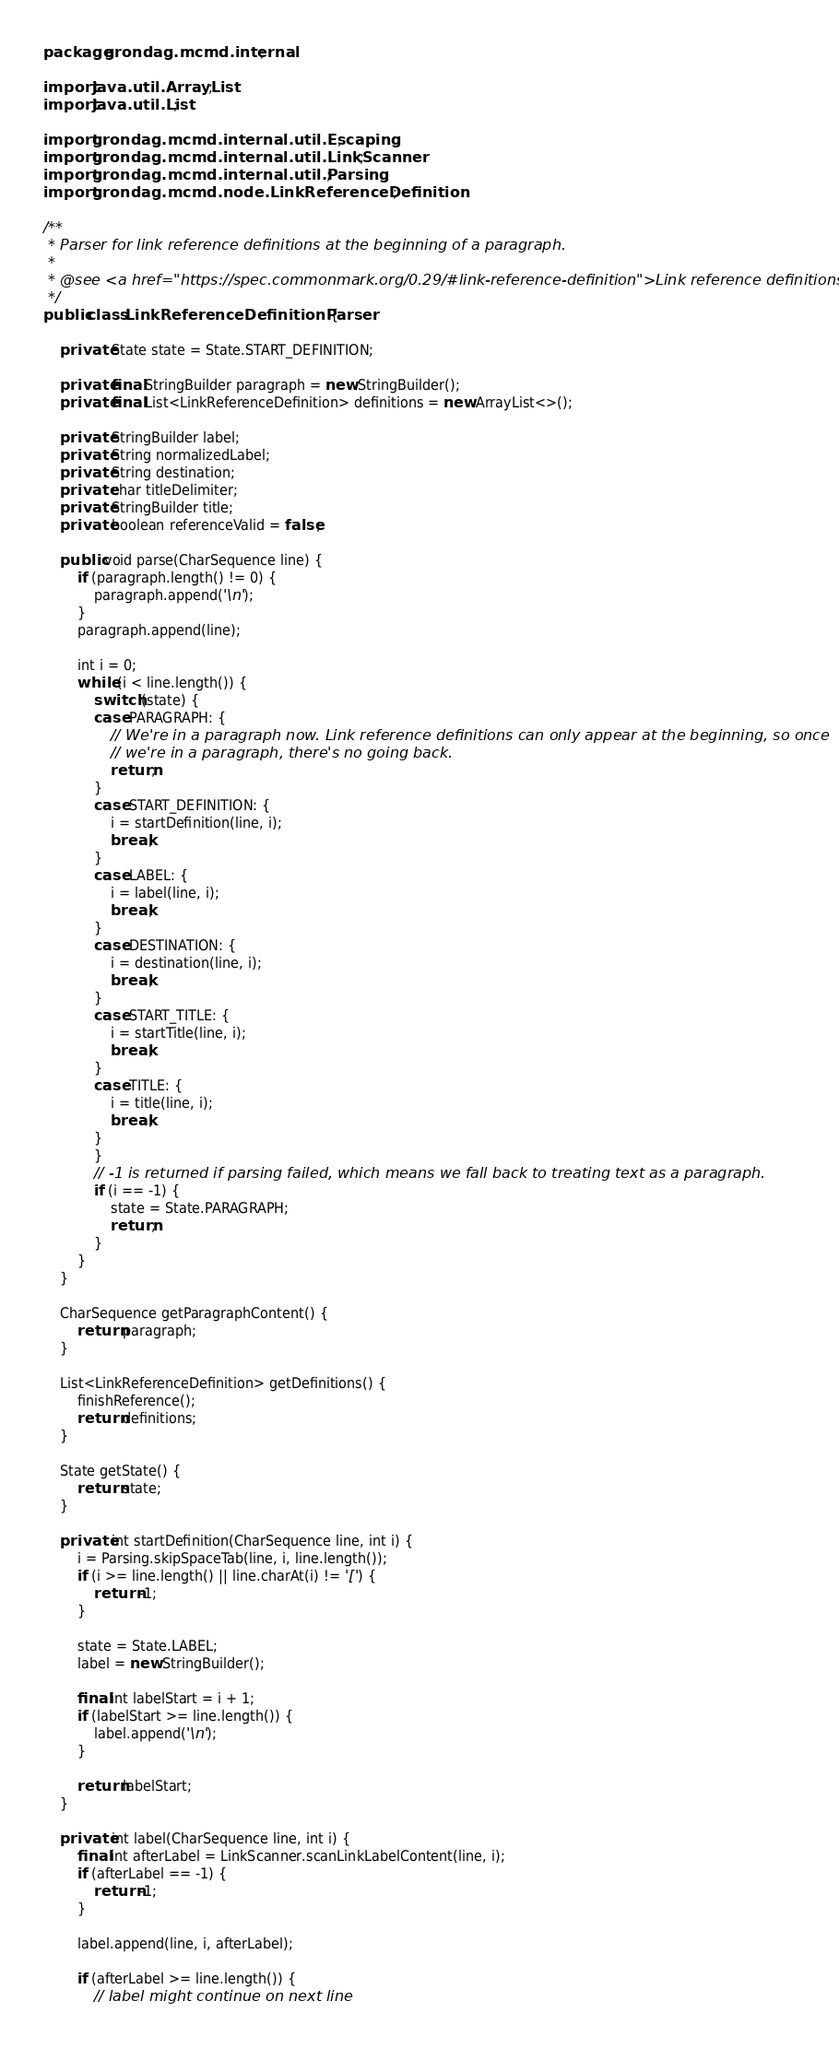<code> <loc_0><loc_0><loc_500><loc_500><_Java_>package grondag.mcmd.internal;

import java.util.ArrayList;
import java.util.List;

import grondag.mcmd.internal.util.Escaping;
import grondag.mcmd.internal.util.LinkScanner;
import grondag.mcmd.internal.util.Parsing;
import grondag.mcmd.node.LinkReferenceDefinition;

/**
 * Parser for link reference definitions at the beginning of a paragraph.
 *
 * @see <a href="https://spec.commonmark.org/0.29/#link-reference-definition">Link reference definitions</a>
 */
public class LinkReferenceDefinitionParser {

	private State state = State.START_DEFINITION;

	private final StringBuilder paragraph = new StringBuilder();
	private final List<LinkReferenceDefinition> definitions = new ArrayList<>();

	private StringBuilder label;
	private String normalizedLabel;
	private String destination;
	private char titleDelimiter;
	private StringBuilder title;
	private boolean referenceValid = false;

	public void parse(CharSequence line) {
		if (paragraph.length() != 0) {
			paragraph.append('\n');
		}
		paragraph.append(line);

		int i = 0;
		while (i < line.length()) {
			switch (state) {
			case PARAGRAPH: {
				// We're in a paragraph now. Link reference definitions can only appear at the beginning, so once
				// we're in a paragraph, there's no going back.
				return;
			}
			case START_DEFINITION: {
				i = startDefinition(line, i);
				break;
			}
			case LABEL: {
				i = label(line, i);
				break;
			}
			case DESTINATION: {
				i = destination(line, i);
				break;
			}
			case START_TITLE: {
				i = startTitle(line, i);
				break;
			}
			case TITLE: {
				i = title(line, i);
				break;
			}
			}
			// -1 is returned if parsing failed, which means we fall back to treating text as a paragraph.
			if (i == -1) {
				state = State.PARAGRAPH;
				return;
			}
		}
	}

	CharSequence getParagraphContent() {
		return paragraph;
	}

	List<LinkReferenceDefinition> getDefinitions() {
		finishReference();
		return definitions;
	}

	State getState() {
		return state;
	}

	private int startDefinition(CharSequence line, int i) {
		i = Parsing.skipSpaceTab(line, i, line.length());
		if (i >= line.length() || line.charAt(i) != '[') {
			return -1;
		}

		state = State.LABEL;
		label = new StringBuilder();

		final int labelStart = i + 1;
		if (labelStart >= line.length()) {
			label.append('\n');
		}

		return labelStart;
	}

	private int label(CharSequence line, int i) {
		final int afterLabel = LinkScanner.scanLinkLabelContent(line, i);
		if (afterLabel == -1) {
			return -1;
		}

		label.append(line, i, afterLabel);

		if (afterLabel >= line.length()) {
			// label might continue on next line</code> 